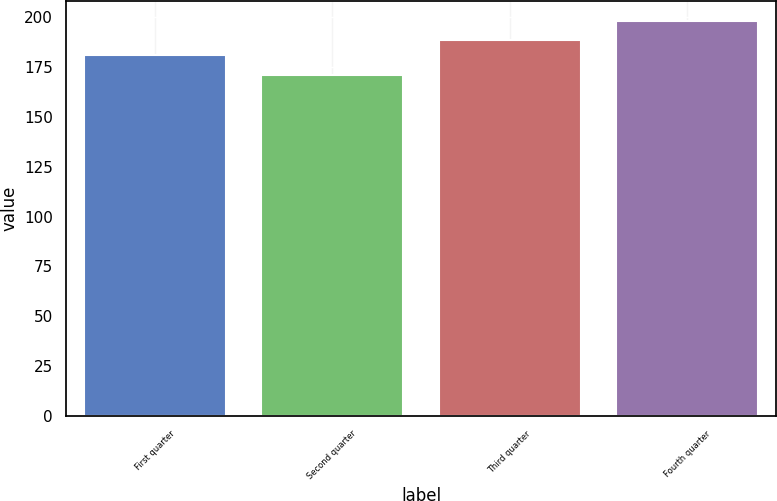Convert chart. <chart><loc_0><loc_0><loc_500><loc_500><bar_chart><fcel>First quarter<fcel>Second quarter<fcel>Third quarter<fcel>Fourth quarter<nl><fcel>181.13<fcel>171.08<fcel>188.58<fcel>198.06<nl></chart> 